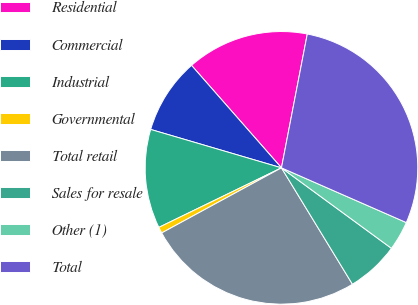Convert chart. <chart><loc_0><loc_0><loc_500><loc_500><pie_chart><fcel>Residential<fcel>Commercial<fcel>Industrial<fcel>Governmental<fcel>Total retail<fcel>Sales for resale<fcel>Other (1)<fcel>Total<nl><fcel>14.5%<fcel>8.99%<fcel>11.74%<fcel>0.73%<fcel>25.79%<fcel>6.23%<fcel>3.48%<fcel>28.54%<nl></chart> 